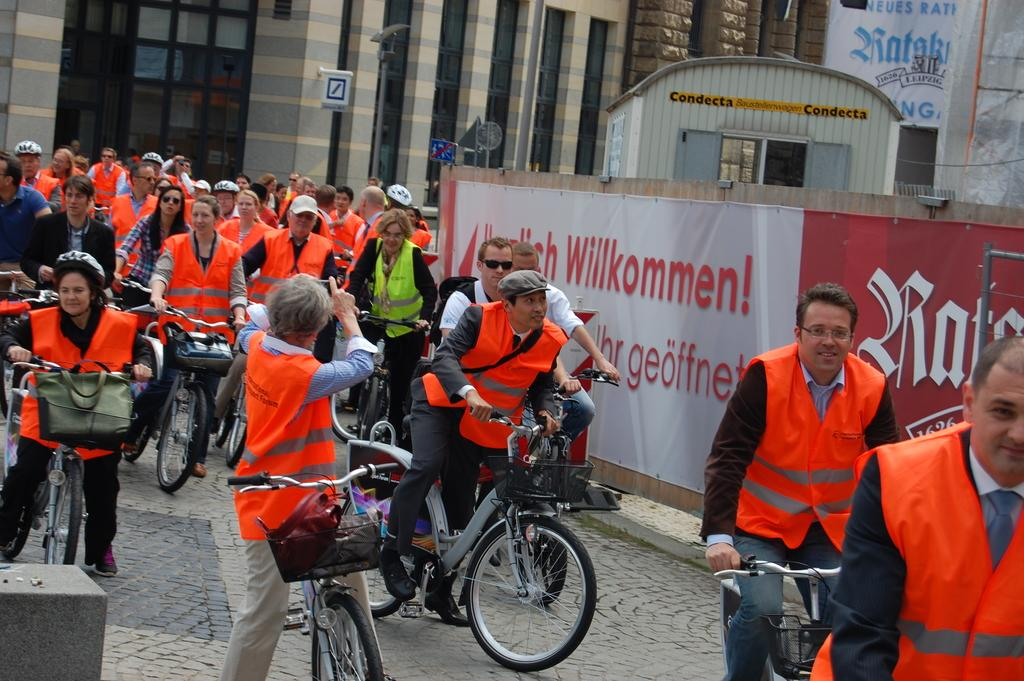What are the people in the image doing? The people in the image are on bicycles. What else can be seen in the image besides the people on bicycles? There is a board visible in the image. What can be seen in the background of the image? There are buildings in the background of the image. What type of music can be heard playing from the board in the image? There is no music or sound present in the image, as it is a still photograph. 